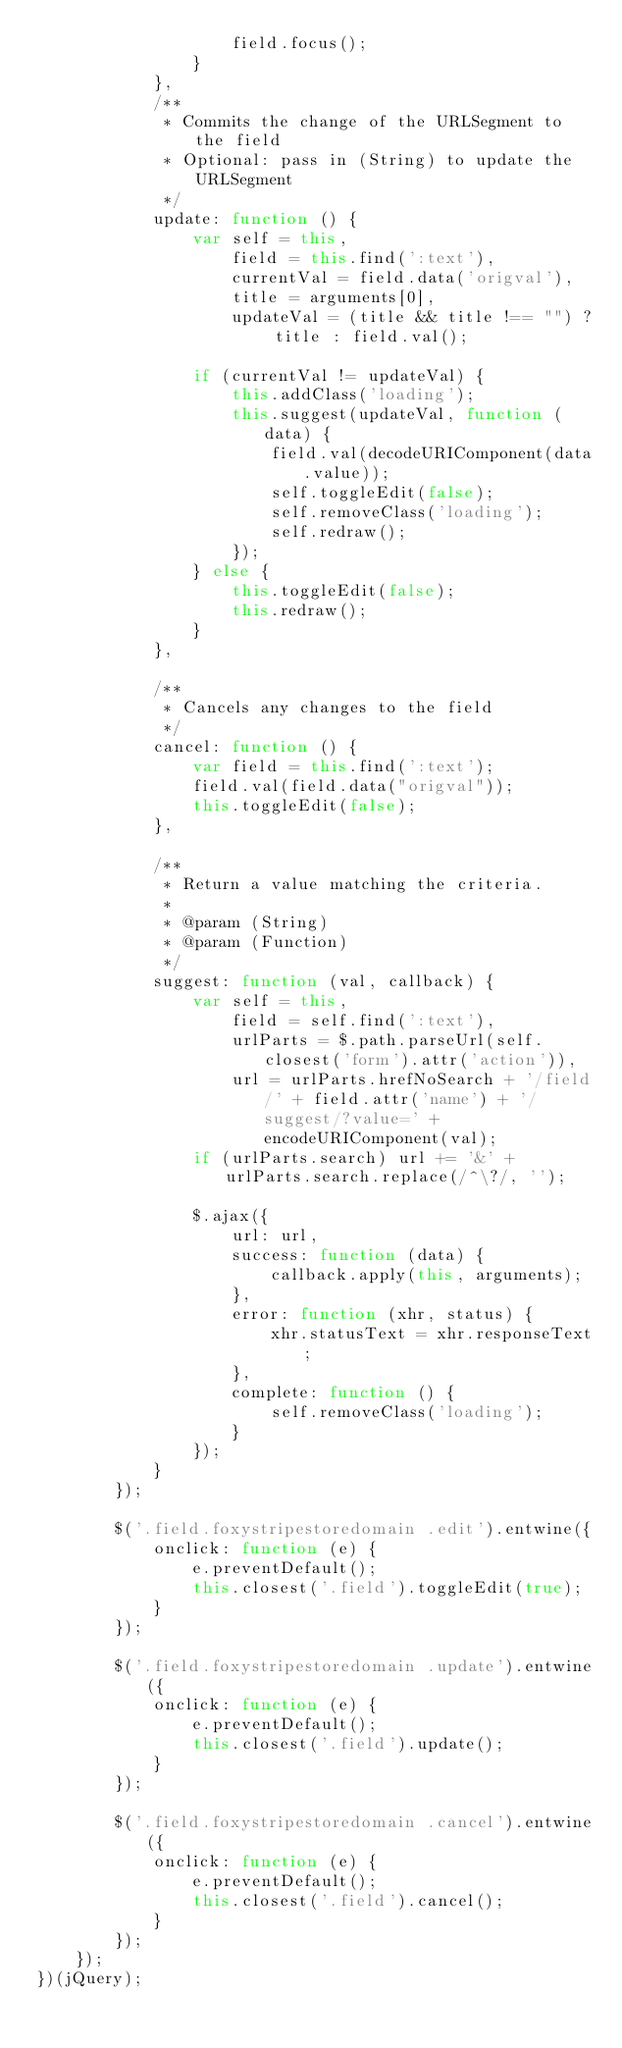Convert code to text. <code><loc_0><loc_0><loc_500><loc_500><_JavaScript_>                    field.focus();
                }
            },
            /**
             * Commits the change of the URLSegment to the field
             * Optional: pass in (String) to update the URLSegment
             */
            update: function () {
                var self = this,
                    field = this.find(':text'),
                    currentVal = field.data('origval'),
                    title = arguments[0],
                    updateVal = (title && title !== "") ? title : field.val();

                if (currentVal != updateVal) {
                    this.addClass('loading');
                    this.suggest(updateVal, function (data) {
                        field.val(decodeURIComponent(data.value));
                        self.toggleEdit(false);
                        self.removeClass('loading');
                        self.redraw();
                    });
                } else {
                    this.toggleEdit(false);
                    this.redraw();
                }
            },

            /**
             * Cancels any changes to the field
             */
            cancel: function () {
                var field = this.find(':text');
                field.val(field.data("origval"));
                this.toggleEdit(false);
            },

            /**
             * Return a value matching the criteria.
             *
             * @param (String)
             * @param (Function)
             */
            suggest: function (val, callback) {
                var self = this,
                    field = self.find(':text'),
                    urlParts = $.path.parseUrl(self.closest('form').attr('action')),
                    url = urlParts.hrefNoSearch + '/field/' + field.attr('name') + '/suggest/?value=' + encodeURIComponent(val);
                if (urlParts.search) url += '&' + urlParts.search.replace(/^\?/, '');

                $.ajax({
                    url: url,
                    success: function (data) {
                        callback.apply(this, arguments);
                    },
                    error: function (xhr, status) {
                        xhr.statusText = xhr.responseText;
                    },
                    complete: function () {
                        self.removeClass('loading');
                    }
                });
            }
        });

        $('.field.foxystripestoredomain .edit').entwine({
            onclick: function (e) {
                e.preventDefault();
                this.closest('.field').toggleEdit(true);
            }
        });

        $('.field.foxystripestoredomain .update').entwine({
            onclick: function (e) {
                e.preventDefault();
                this.closest('.field').update();
            }
        });

        $('.field.foxystripestoredomain .cancel').entwine({
            onclick: function (e) {
                e.preventDefault();
                this.closest('.field').cancel();
            }
        });
    });
})(jQuery);
</code> 